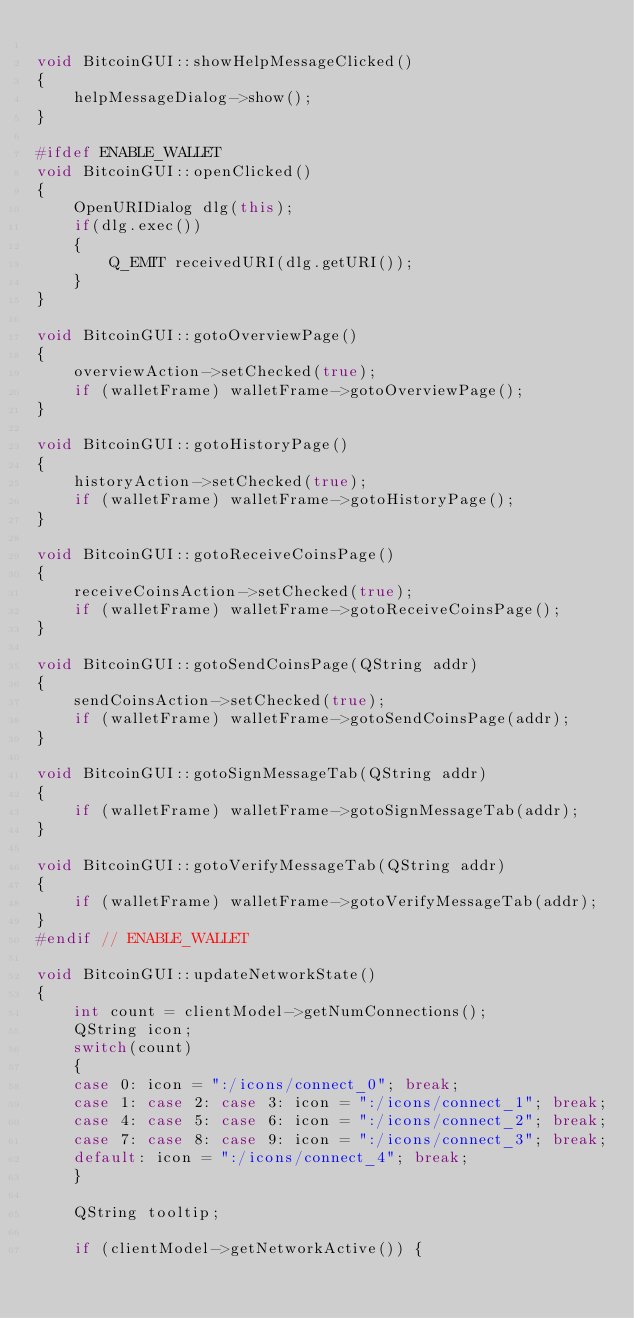<code> <loc_0><loc_0><loc_500><loc_500><_C++_>
void BitcoinGUI::showHelpMessageClicked()
{
    helpMessageDialog->show();
}

#ifdef ENABLE_WALLET
void BitcoinGUI::openClicked()
{
    OpenURIDialog dlg(this);
    if(dlg.exec())
    {
        Q_EMIT receivedURI(dlg.getURI());
    }
}

void BitcoinGUI::gotoOverviewPage()
{
    overviewAction->setChecked(true);
    if (walletFrame) walletFrame->gotoOverviewPage();
}

void BitcoinGUI::gotoHistoryPage()
{
    historyAction->setChecked(true);
    if (walletFrame) walletFrame->gotoHistoryPage();
}

void BitcoinGUI::gotoReceiveCoinsPage()
{
    receiveCoinsAction->setChecked(true);
    if (walletFrame) walletFrame->gotoReceiveCoinsPage();
}

void BitcoinGUI::gotoSendCoinsPage(QString addr)
{
    sendCoinsAction->setChecked(true);
    if (walletFrame) walletFrame->gotoSendCoinsPage(addr);
}

void BitcoinGUI::gotoSignMessageTab(QString addr)
{
    if (walletFrame) walletFrame->gotoSignMessageTab(addr);
}

void BitcoinGUI::gotoVerifyMessageTab(QString addr)
{
    if (walletFrame) walletFrame->gotoVerifyMessageTab(addr);
}
#endif // ENABLE_WALLET

void BitcoinGUI::updateNetworkState()
{
    int count = clientModel->getNumConnections();
    QString icon;
    switch(count)
    {
    case 0: icon = ":/icons/connect_0"; break;
    case 1: case 2: case 3: icon = ":/icons/connect_1"; break;
    case 4: case 5: case 6: icon = ":/icons/connect_2"; break;
    case 7: case 8: case 9: icon = ":/icons/connect_3"; break;
    default: icon = ":/icons/connect_4"; break;
    }

    QString tooltip;

    if (clientModel->getNetworkActive()) {</code> 